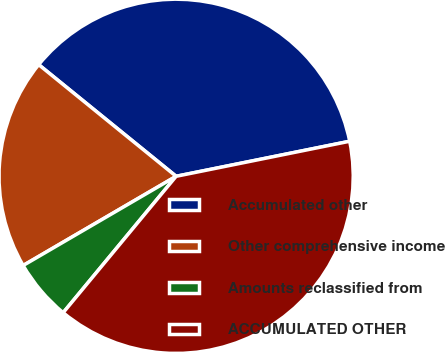Convert chart to OTSL. <chart><loc_0><loc_0><loc_500><loc_500><pie_chart><fcel>Accumulated other<fcel>Other comprehensive income<fcel>Amounts reclassified from<fcel>ACCUMULATED OTHER<nl><fcel>35.97%<fcel>19.26%<fcel>5.59%<fcel>39.18%<nl></chart> 